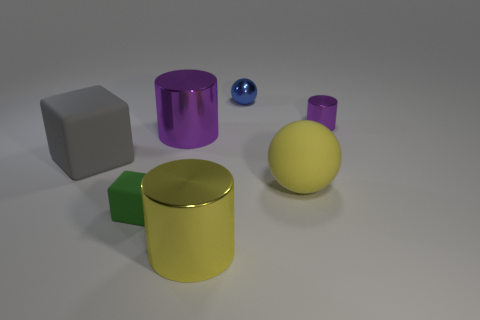Subtract all tiny cylinders. How many cylinders are left? 2 Subtract 1 cylinders. How many cylinders are left? 2 Add 1 big gray rubber things. How many objects exist? 8 Subtract all cubes. How many objects are left? 5 Subtract all red metal things. Subtract all big gray objects. How many objects are left? 6 Add 6 yellow matte objects. How many yellow matte objects are left? 7 Add 6 blue matte cylinders. How many blue matte cylinders exist? 6 Subtract 0 cyan balls. How many objects are left? 7 